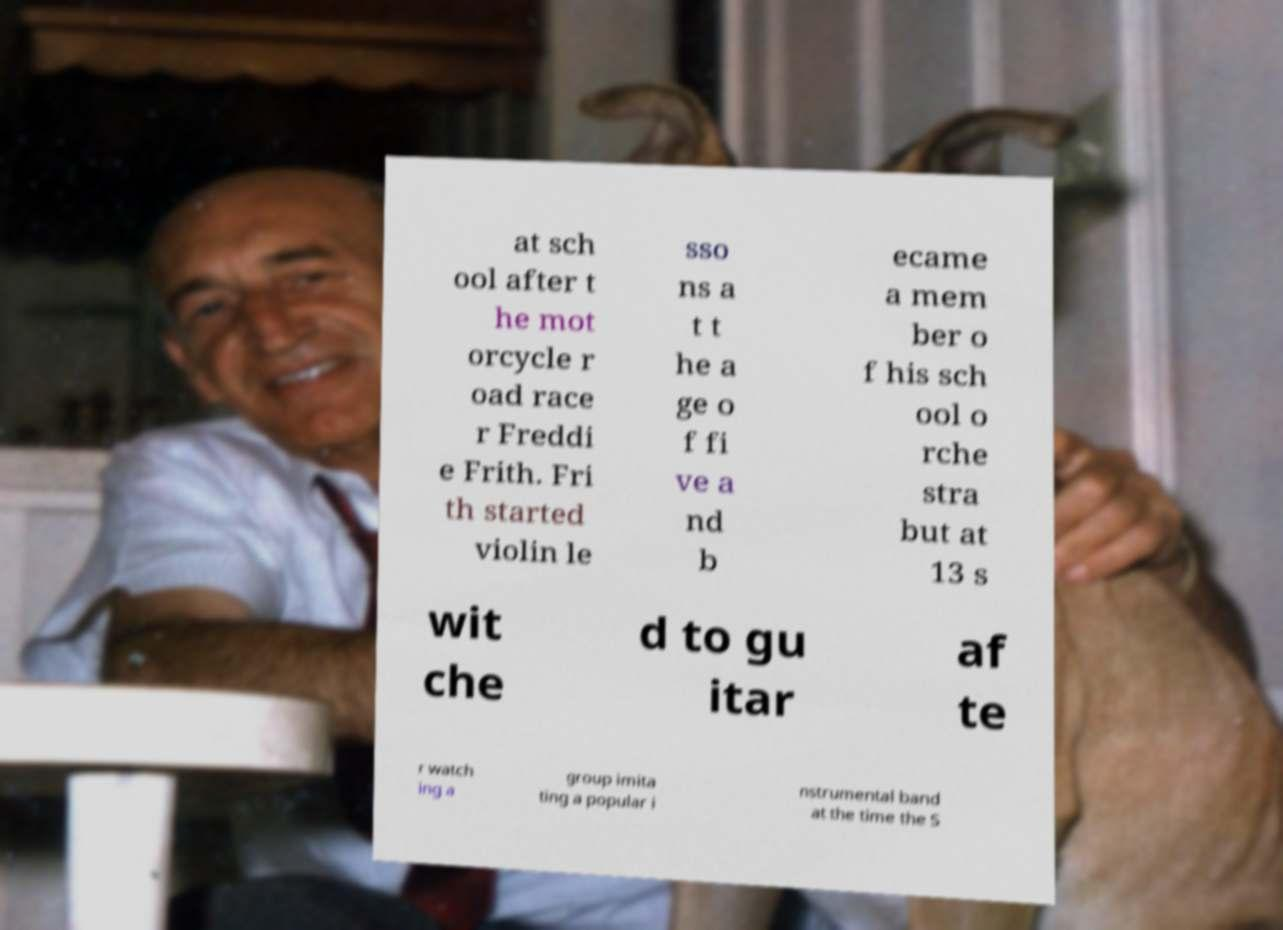Could you assist in decoding the text presented in this image and type it out clearly? at sch ool after t he mot orcycle r oad race r Freddi e Frith. Fri th started violin le sso ns a t t he a ge o f fi ve a nd b ecame a mem ber o f his sch ool o rche stra but at 13 s wit che d to gu itar af te r watch ing a group imita ting a popular i nstrumental band at the time the S 